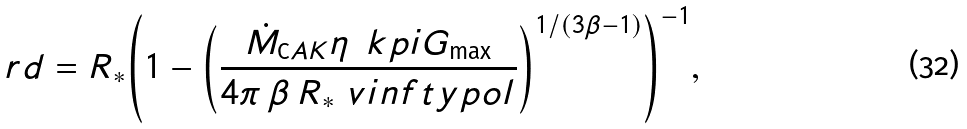Convert formula to latex. <formula><loc_0><loc_0><loc_500><loc_500>\ r d = R _ { * } { \left ( 1 - { \left ( \frac { \dot { M } _ { \mathrm C A K } \eta \, \ k p i G _ { \mathrm \max } } { 4 \pi \, \beta \, { R _ { * } } \ v i n f t y p o l } \right ) } ^ { { 1 } / { ( 3 \beta - 1 ) } } \right ) } ^ { - 1 } ,</formula> 